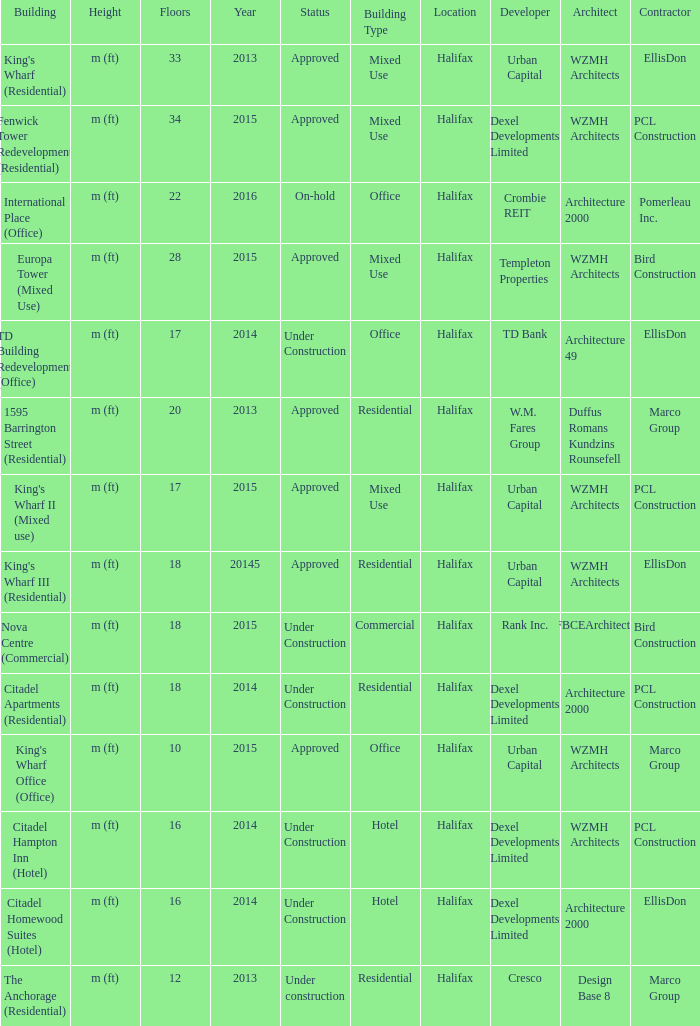What is the status of the building with less than 18 floors and later than 2013? Under Construction, Approved, Approved, Under Construction, Under Construction. 